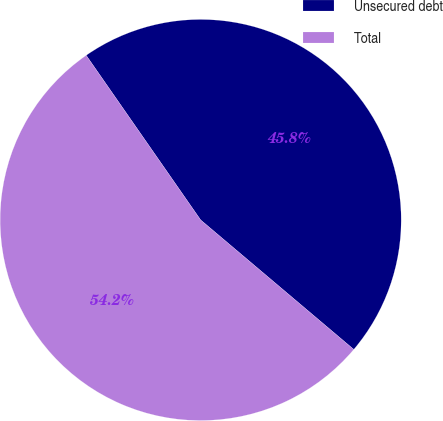Convert chart. <chart><loc_0><loc_0><loc_500><loc_500><pie_chart><fcel>Unsecured debt<fcel>Total<nl><fcel>45.84%<fcel>54.16%<nl></chart> 